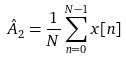<formula> <loc_0><loc_0><loc_500><loc_500>\hat { A } _ { 2 } = \frac { 1 } { N } \sum _ { n = 0 } ^ { N - 1 } x [ n ]</formula> 